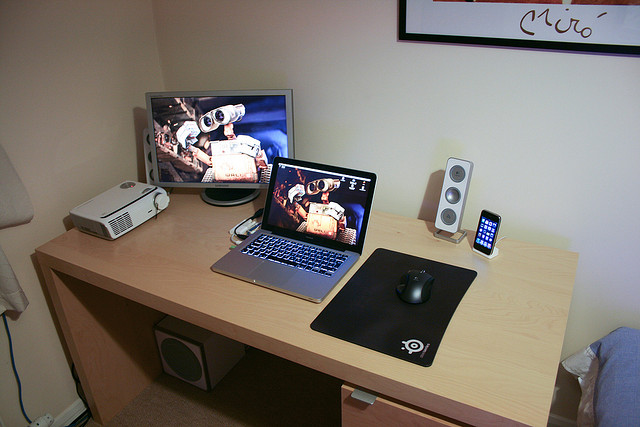<image>What brand is the mouse pad? I don't know what brand the mouse pad is. It could be HP, Samsung, Dell, Apple, Logitech, or Naga. What brand is the mouse pad? I am not aware of what brand the mouse pad is. 